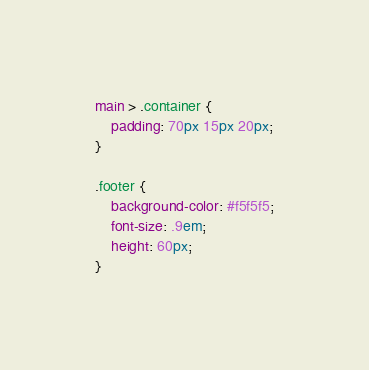<code> <loc_0><loc_0><loc_500><loc_500><_CSS_>main > .container {
    padding: 70px 15px 20px;
}

.footer {
    background-color: #f5f5f5;
    font-size: .9em;
    height: 60px;
}
</code> 